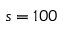<formula> <loc_0><loc_0><loc_500><loc_500>s = 1 0 0</formula> 